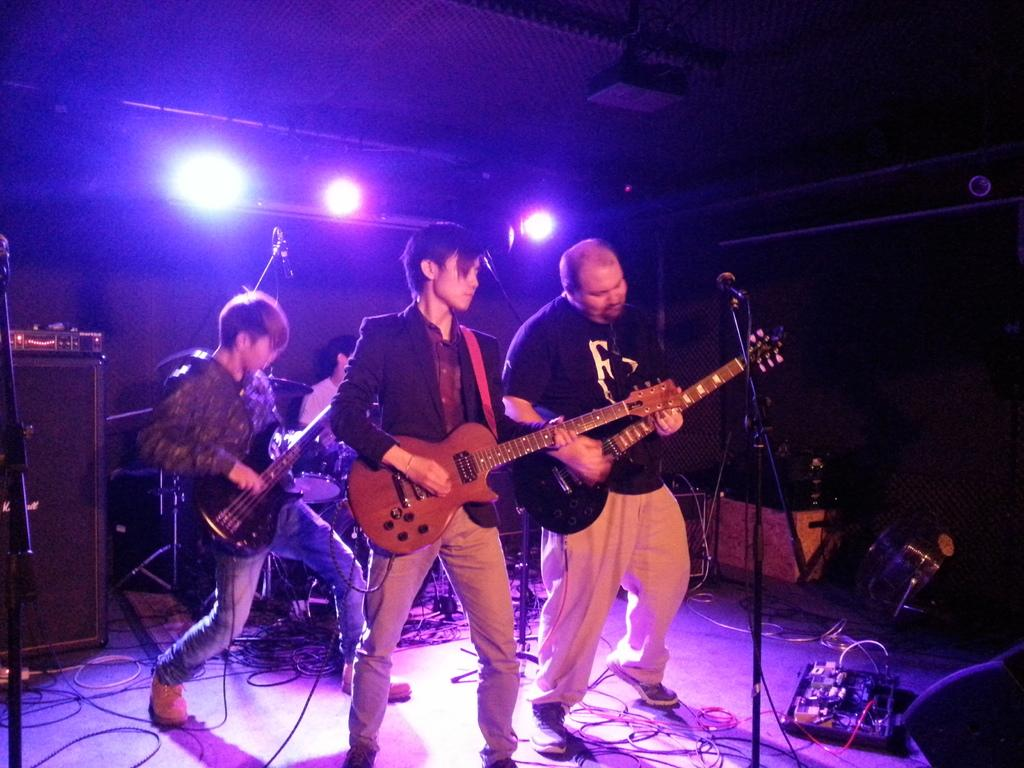How many people are in the image? There are three men in the image. What are the men doing in the image? The men are playing guitars. What can be seen in the background of the image? There are lights and musical instruments in the background of the image. How many knives are visible in the image? There are no knives present in the image. What is the amount of oatmeal being served in the image? There is no oatmeal present in the image. 